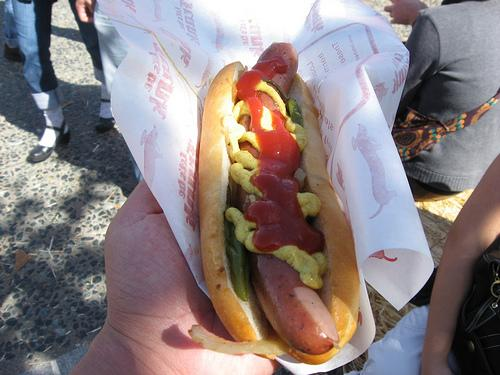Which ingredient contains the highest amount of sodium?

Choices:
A) cucumber
B) ketchup
C) sausage
D) mustard sausage 